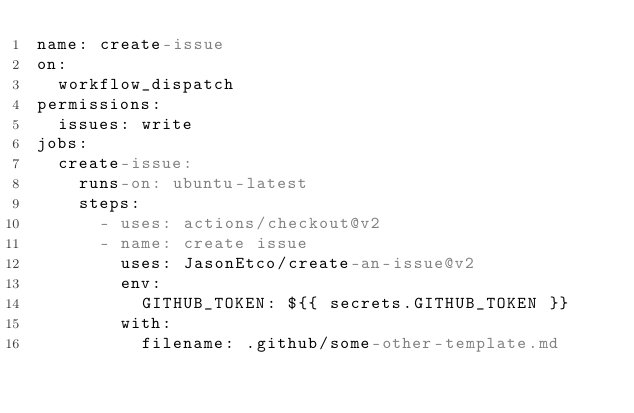Convert code to text. <code><loc_0><loc_0><loc_500><loc_500><_YAML_>name: create-issue
on:
  workflow_dispatch
permissions:
  issues: write
jobs:
  create-issue:
    runs-on: ubuntu-latest
    steps:
      - uses: actions/checkout@v2
      - name: create issue
        uses: JasonEtco/create-an-issue@v2
        env:
          GITHUB_TOKEN: ${{ secrets.GITHUB_TOKEN }}
        with:
          filename: .github/some-other-template.md
    
</code> 